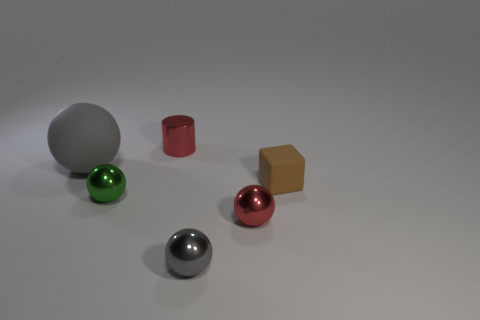How many other things are there of the same color as the metal cylinder? In the image, the metal cylinder appears to be silver-colored. After examining the other objects, it seems that there is only one other item sharing a similar silver hue, a spherical object. So there is just one item of the same color as the metal cylinder. 